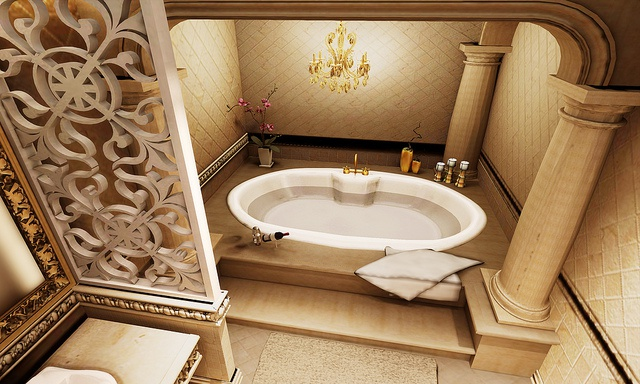Describe the objects in this image and their specific colors. I can see sink in tan and lightgray tones, potted plant in tan, maroon, black, and brown tones, sink in tan and lightgray tones, potted plant in tan, red, maroon, and black tones, and vase in tan, maroon, black, and gray tones in this image. 